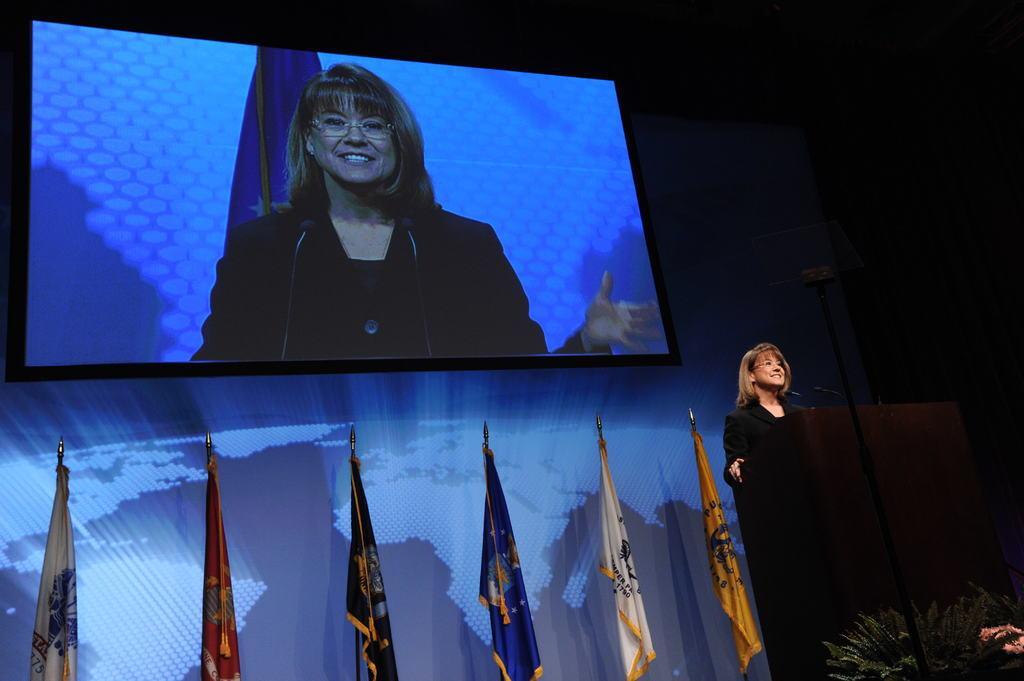Can you describe this image briefly? In this image I see a woman who is smiling and she is wearing black dress and I see a podium in front of her on which there is a mic over here. In the background I see the flags which are of different colors and I see the screen over here on which I see the woman who is standing over here and it is dark over here. 